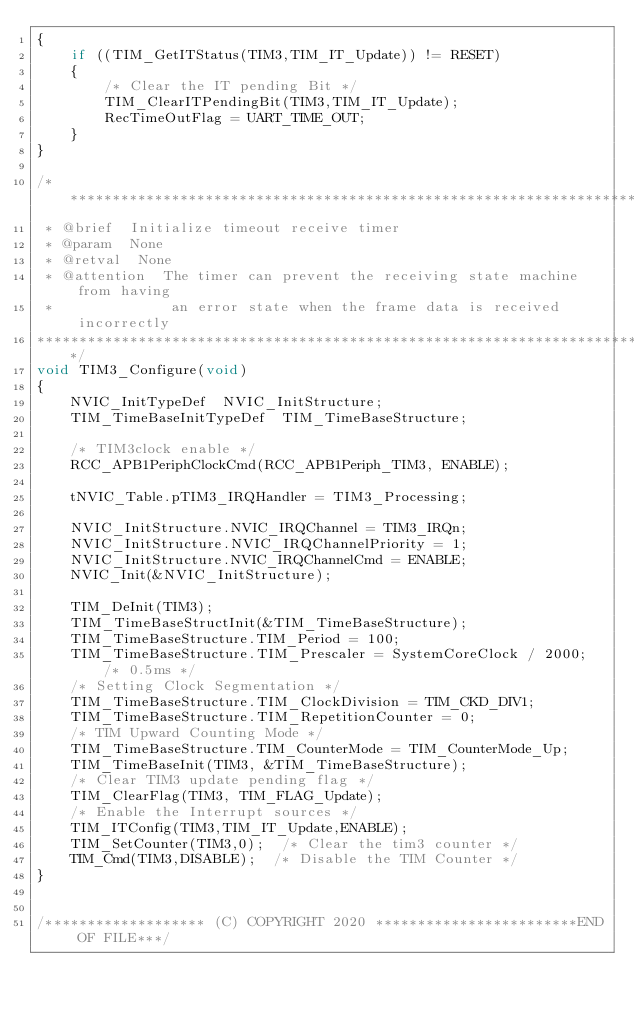<code> <loc_0><loc_0><loc_500><loc_500><_C_>{
    if ((TIM_GetITStatus(TIM3,TIM_IT_Update)) != RESET)
    {
        /* Clear the IT pending Bit */
        TIM_ClearITPendingBit(TIM3,TIM_IT_Update);
        RecTimeOutFlag = UART_TIME_OUT;
    }
}

/******************************************************************************
 * @brief  Initialize timeout receive timer
 * @param  None
 * @retval  None
 * @attention  The timer can prevent the receiving state machine from having 
 *              an error state when the frame data is received incorrectly
******************************************************************************/
void TIM3_Configure(void)
{
    NVIC_InitTypeDef  NVIC_InitStructure;
    TIM_TimeBaseInitTypeDef  TIM_TimeBaseStructure;
    
    /* TIM3clock enable */
    RCC_APB1PeriphClockCmd(RCC_APB1Periph_TIM3, ENABLE); 
    
    tNVIC_Table.pTIM3_IRQHandler = TIM3_Processing;

    NVIC_InitStructure.NVIC_IRQChannel = TIM3_IRQn;
    NVIC_InitStructure.NVIC_IRQChannelPriority = 1;
    NVIC_InitStructure.NVIC_IRQChannelCmd = ENABLE;
    NVIC_Init(&NVIC_InitStructure);
    
    TIM_DeInit(TIM3);
    TIM_TimeBaseStructInit(&TIM_TimeBaseStructure);
    TIM_TimeBaseStructure.TIM_Period = 100;
    TIM_TimeBaseStructure.TIM_Prescaler = SystemCoreClock / 2000;  /* 0.5ms */
    /* Setting Clock Segmentation */
    TIM_TimeBaseStructure.TIM_ClockDivision = TIM_CKD_DIV1;
    TIM_TimeBaseStructure.TIM_RepetitionCounter = 0;
    /* TIM Upward Counting Mode */
    TIM_TimeBaseStructure.TIM_CounterMode = TIM_CounterMode_Up;
    TIM_TimeBaseInit(TIM3, &TIM_TimeBaseStructure);
    /* Clear TIM3 update pending flag */
    TIM_ClearFlag(TIM3, TIM_FLAG_Update);      
    /* Enable the Interrupt sources */
    TIM_ITConfig(TIM3,TIM_IT_Update,ENABLE);
    TIM_SetCounter(TIM3,0);  /* Clear the tim3 counter */
    TIM_Cmd(TIM3,DISABLE);  /* Disable the TIM Counter */
}


/******************* (C) COPYRIGHT 2020 ************************END OF FILE***/

</code> 